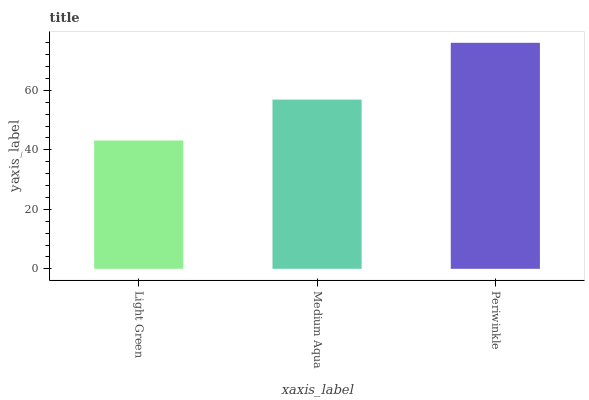Is Light Green the minimum?
Answer yes or no. Yes. Is Periwinkle the maximum?
Answer yes or no. Yes. Is Medium Aqua the minimum?
Answer yes or no. No. Is Medium Aqua the maximum?
Answer yes or no. No. Is Medium Aqua greater than Light Green?
Answer yes or no. Yes. Is Light Green less than Medium Aqua?
Answer yes or no. Yes. Is Light Green greater than Medium Aqua?
Answer yes or no. No. Is Medium Aqua less than Light Green?
Answer yes or no. No. Is Medium Aqua the high median?
Answer yes or no. Yes. Is Medium Aqua the low median?
Answer yes or no. Yes. Is Light Green the high median?
Answer yes or no. No. Is Periwinkle the low median?
Answer yes or no. No. 